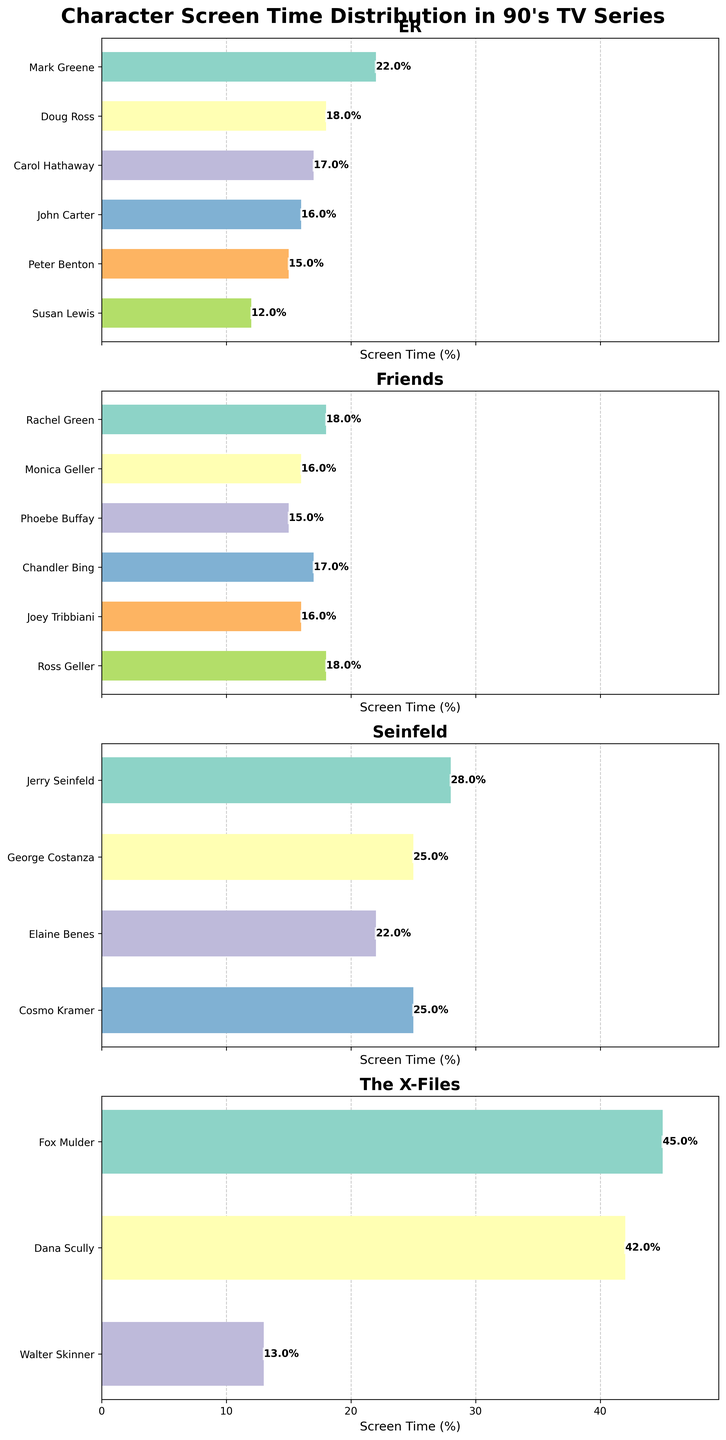What is the title of the figure? The title is located at the top of the figure. It reads "Character Screen Time Distribution in 90's TV Series" in bold and large font.
Answer: Character Screen Time Distribution in 90's TV Series Which character from 'Seinfeld' has the highest screen time? In the subplot for 'Seinfeld', look for the longest bar. The longest bar is for Jerry Seinfeld with a screen time of 28%.
Answer: Jerry Seinfeld Is Ross Geller's screen time higher than Monica Geller's in 'Friends'? In the subplot for 'Friends', compare the bars for Ross Geller and Monica Geller. Ross Geller's bar is at 18%, while Monica Geller's is at 16%, which is lower.
Answer: Yes What is the combined screen time for Fox Mulder and Dana Scully in 'The X-Files'? In the subplot for 'The X-Files', add the screen times of Fox Mulder and Dana Scully. Fox Mulder has 45% and Dana Scully has 42%, so the combined screen time is 45% + 42% = 87%.
Answer: 87% Which series has the most evenly distributed screen time among its characters? Look at the lengths of the bars for each series. 'Friends' has five characters with screen times close to each other: 18%, 16%, 15%, 17%, and 16%. This distribution is more even compared to the others.
Answer: Friends Who has a higher screen time: Cosmo Kramer in 'Seinfeld' or John Carter in 'ER'? Compare the bars for Cosmo Kramer in the 'Seinfeld' subplot and John Carter in the 'ER' subplot. Cosmo Kramer's bar is at 25%, while John Carter's is at 16%.
Answer: Cosmo Kramer How does Walter Skinner's screen time in 'The X-Files' compare to Susan Lewis's in 'ER'? Compare the bars for Walter Skinner in 'The X-Files' subplot and Susan Lewis in 'ER'. Walter Skinner has a screen time of 13% and Susan Lewis has a screen time of 12%.
Answer: Walter Skinner has higher screen time What percentage of screen time does Chandler Bing have in 'Friends'? In the subplot for 'Friends', check the bar labeled Chandler Bing. The bar shows Chandler Bing has a screen time of 17%.
Answer: 17% Which character has the least screen time in 'ER'? Look for the shortest bar in the 'ER' subplot. The shortest bar belongs to Susan Lewis with a screen time of 12%.
Answer: Susan Lewis 